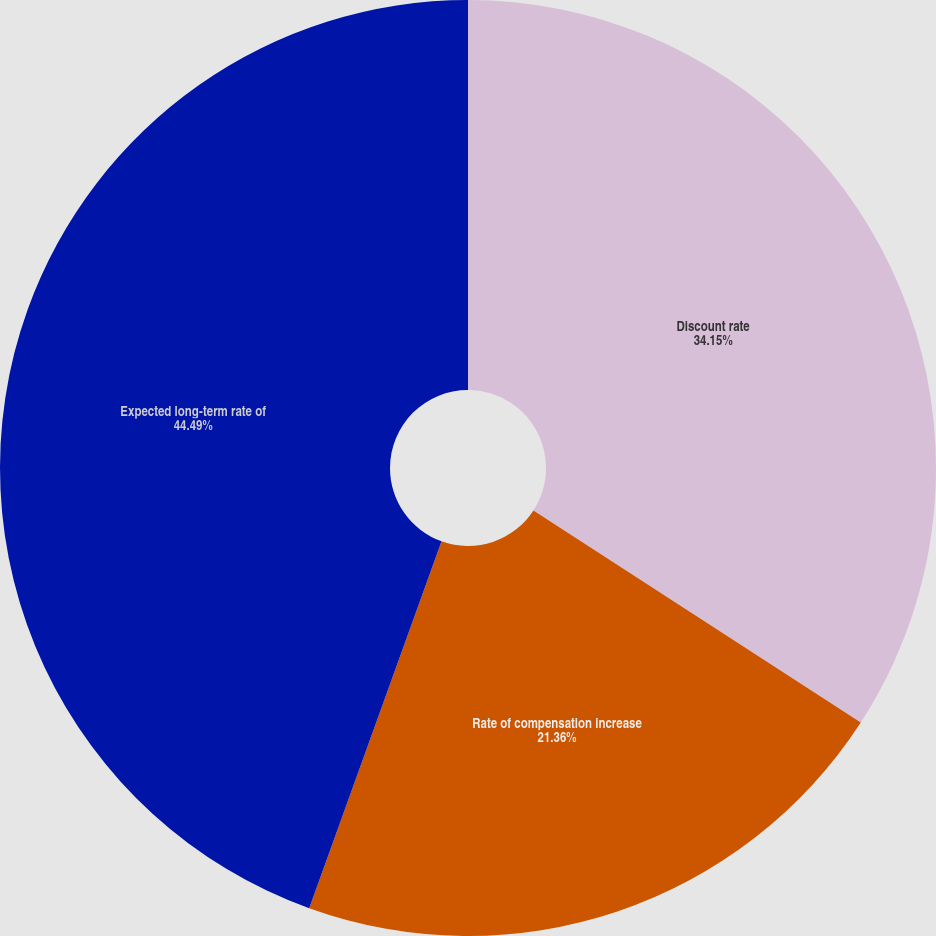Convert chart to OTSL. <chart><loc_0><loc_0><loc_500><loc_500><pie_chart><fcel>Discount rate<fcel>Rate of compensation increase<fcel>Expected long-term rate of<nl><fcel>34.15%<fcel>21.36%<fcel>44.49%<nl></chart> 